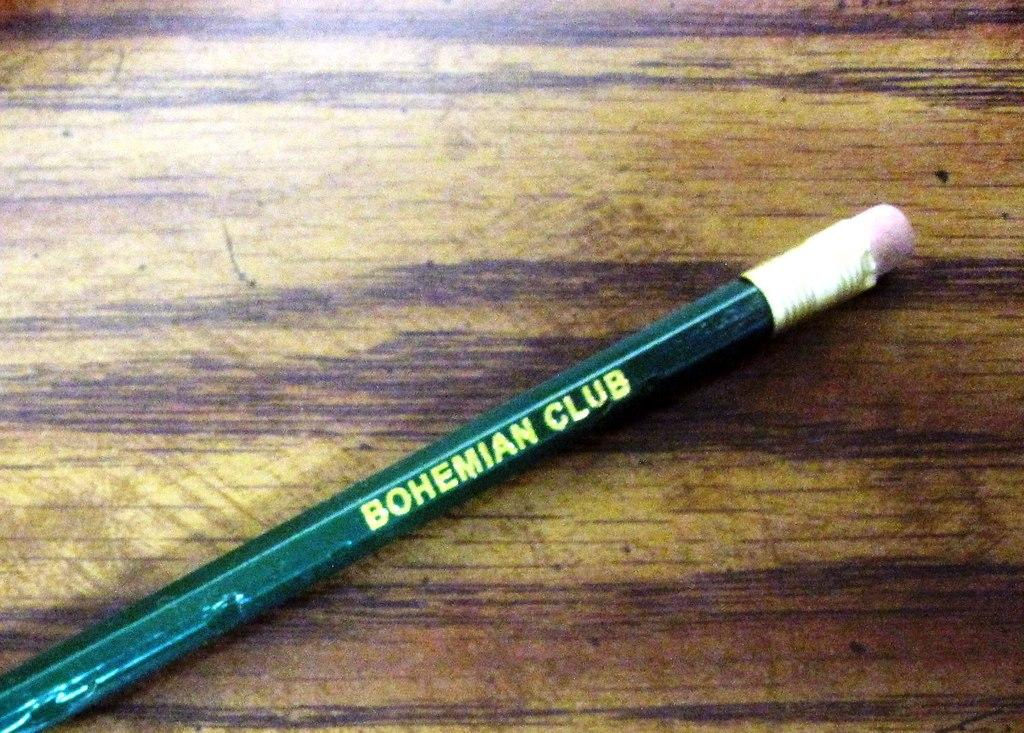What object is present in the image? There is a pencil in the image. Where is the pencil located? The pencil is on a wooden platform. What type of flame can be seen coming from the pencil in the image? There is no flame present in the image; it is a pencil on a wooden platform. 